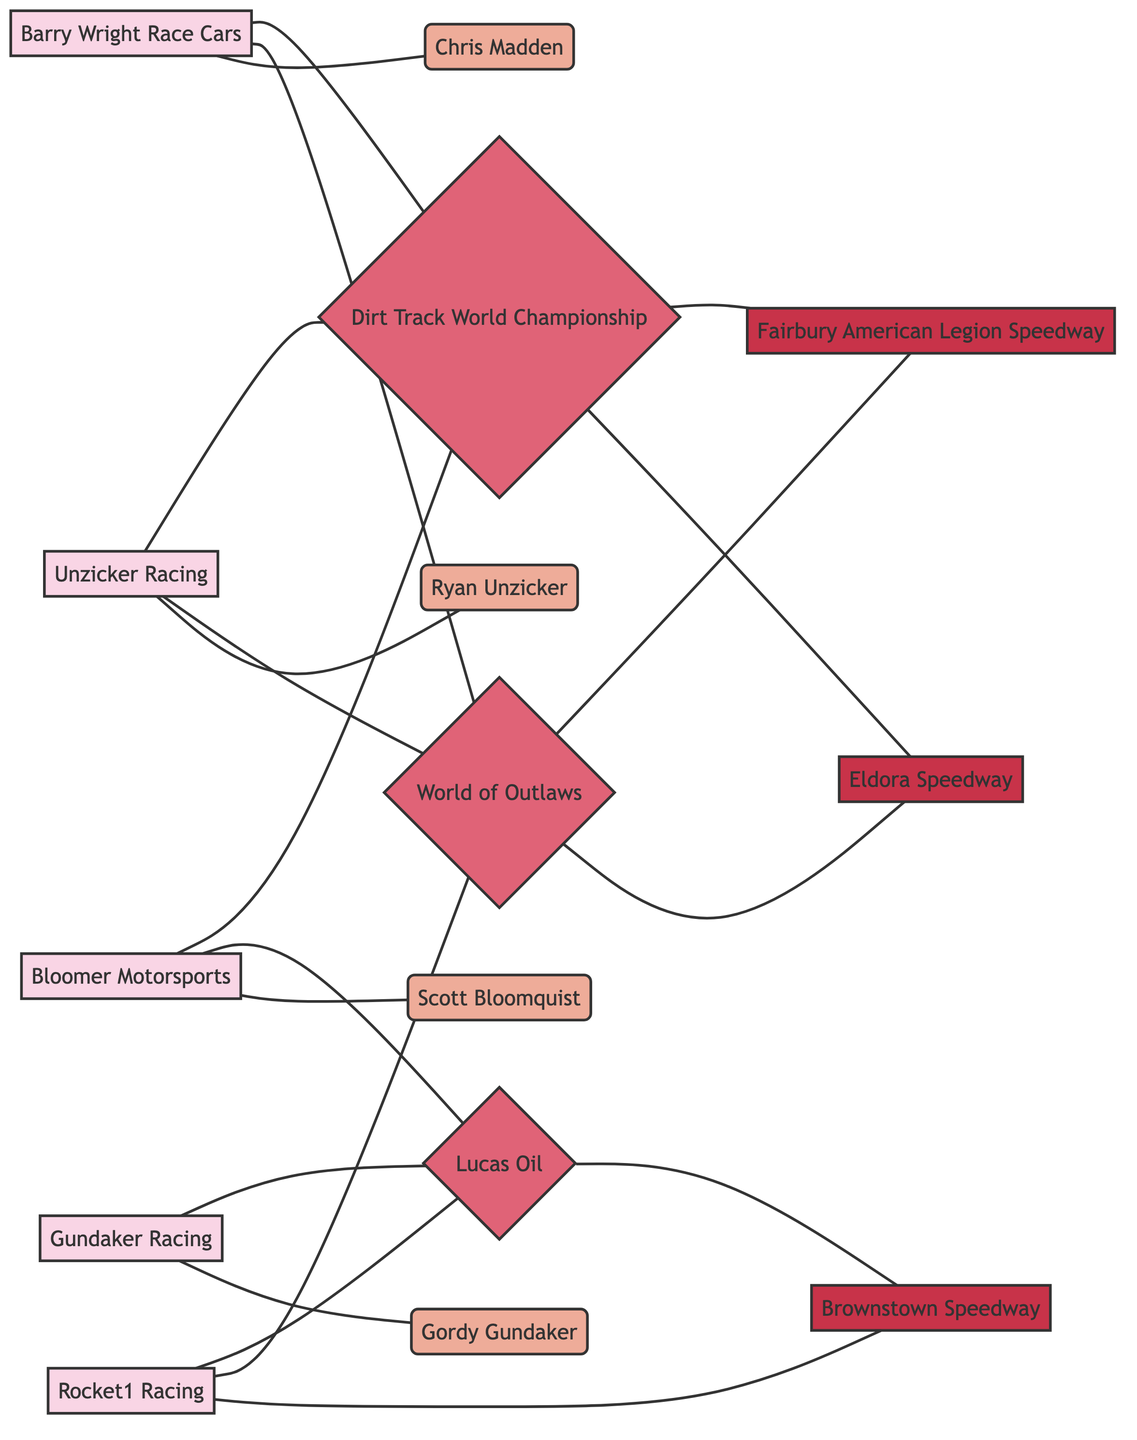What is the name of the driver for Unzicker Racing? According to the diagram, Unzicker Racing has a direct link to the driver Ryan Unzicker.
Answer: Ryan Unzicker How many teams are participating in the World of Outlaws Late Model Series? The link from the race node "World of Outlaws" connects to three team nodes: Unzicker Racing, Rocket1 Racing, and Barry Wright Race Cars, indicating there are three teams involved.
Answer: 3 Which race is held at Eldora Speedway? The diagram shows that Eldora Speedway has links to two race nodes: World of Outlaws Late Model Series and Dirt Track World Championship, meaning both races are held at this location.
Answer: two Who are the drivers associated with Bloomer Motorsports? The diagram displays a direct connection from the team node Bloomer Motorsports to the driver node Scott Bloomquist, indicating he is the sole driver for the team.
Answer: Scott Bloomquist Which team shares a race with Gundaker Racing? Looking at the Lucas Oil Late Model Dirt Series connection in the diagram, Gundaker Racing shares it with Bloomer Motorsports and Rocket1 Racing, linked to that race together.
Answer: Bloomer Motorsports and Rocket1 Racing How many locations are linked to the Dirt Track World Championship? The diagram shows that Dirt Track World Championship links to two locations: Eldora Speedway and Fairbury American Legion Speedway, indicating the championship is hosted at these two places.
Answer: 2 What type of graph is represented by this diagram? This diagram exhibits an undirected graph format, where nodes represent teams, drivers, races, and locations without a specific direction of connection, illustrating their relationships.
Answer: Undirected Graph What race does Unzicker Racing participate in other than World of Outlaws Late Model Series? The diagram reveals that Unzicker Racing also competes in the Dirt Track World Championship, shown by another direct connection.
Answer: Dirt Track World Championship 